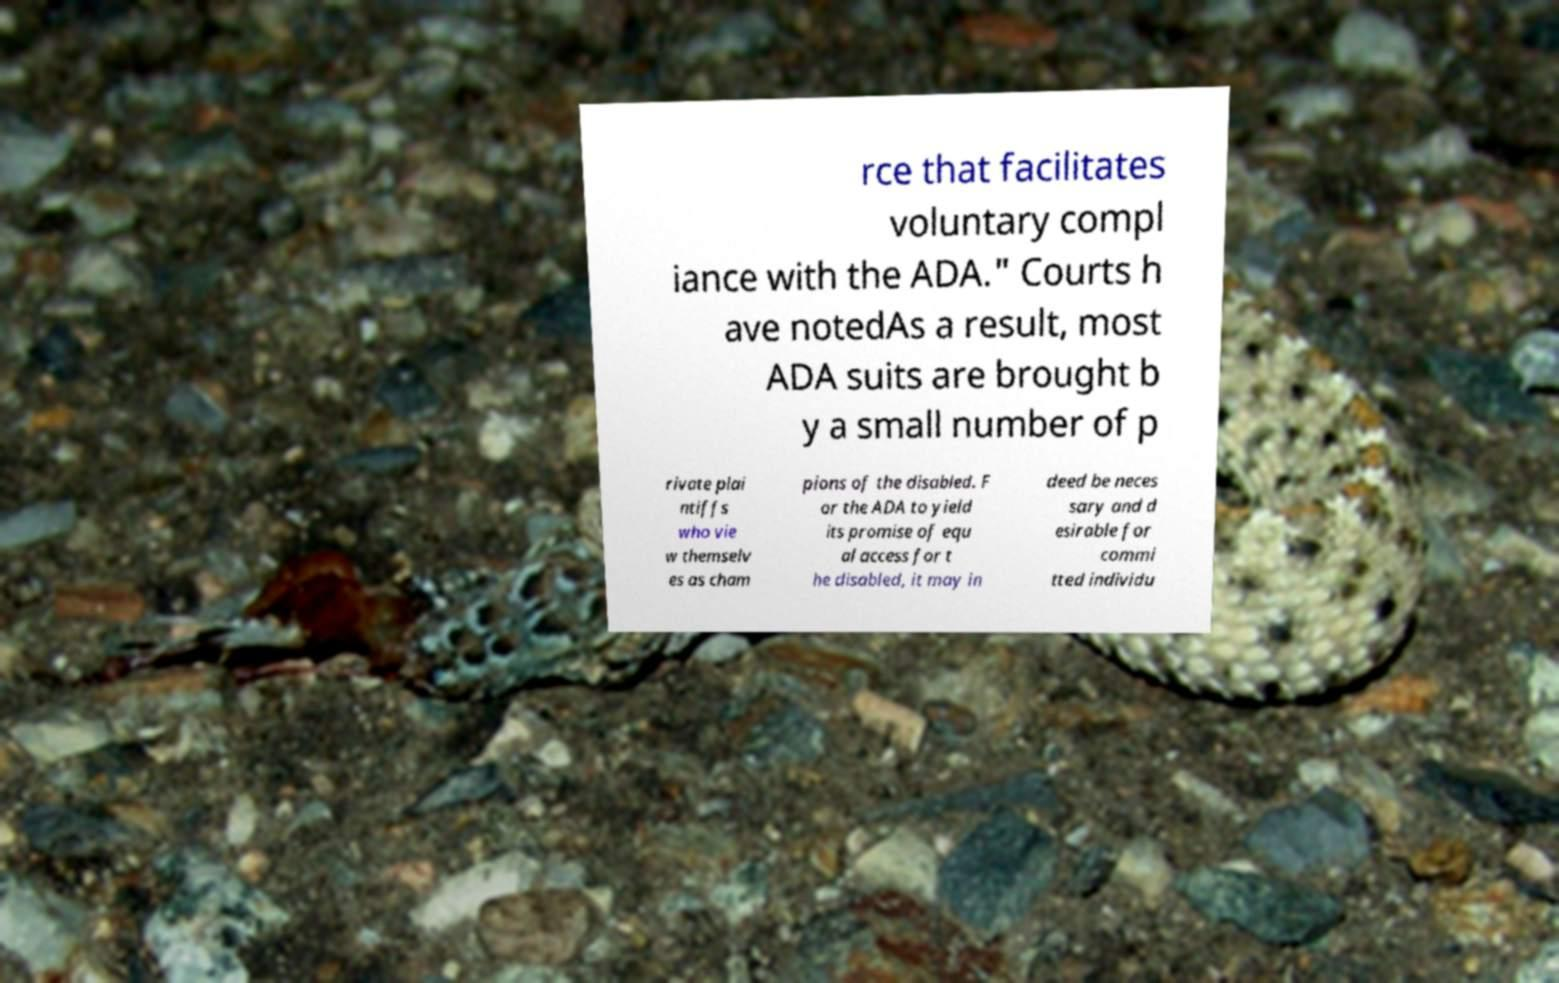I need the written content from this picture converted into text. Can you do that? rce that facilitates voluntary compl iance with the ADA." Courts h ave notedAs a result, most ADA suits are brought b y a small number of p rivate plai ntiffs who vie w themselv es as cham pions of the disabled. F or the ADA to yield its promise of equ al access for t he disabled, it may in deed be neces sary and d esirable for commi tted individu 